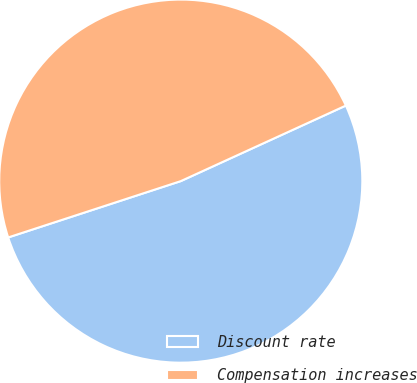<chart> <loc_0><loc_0><loc_500><loc_500><pie_chart><fcel>Discount rate<fcel>Compensation increases<nl><fcel>51.81%<fcel>48.19%<nl></chart> 